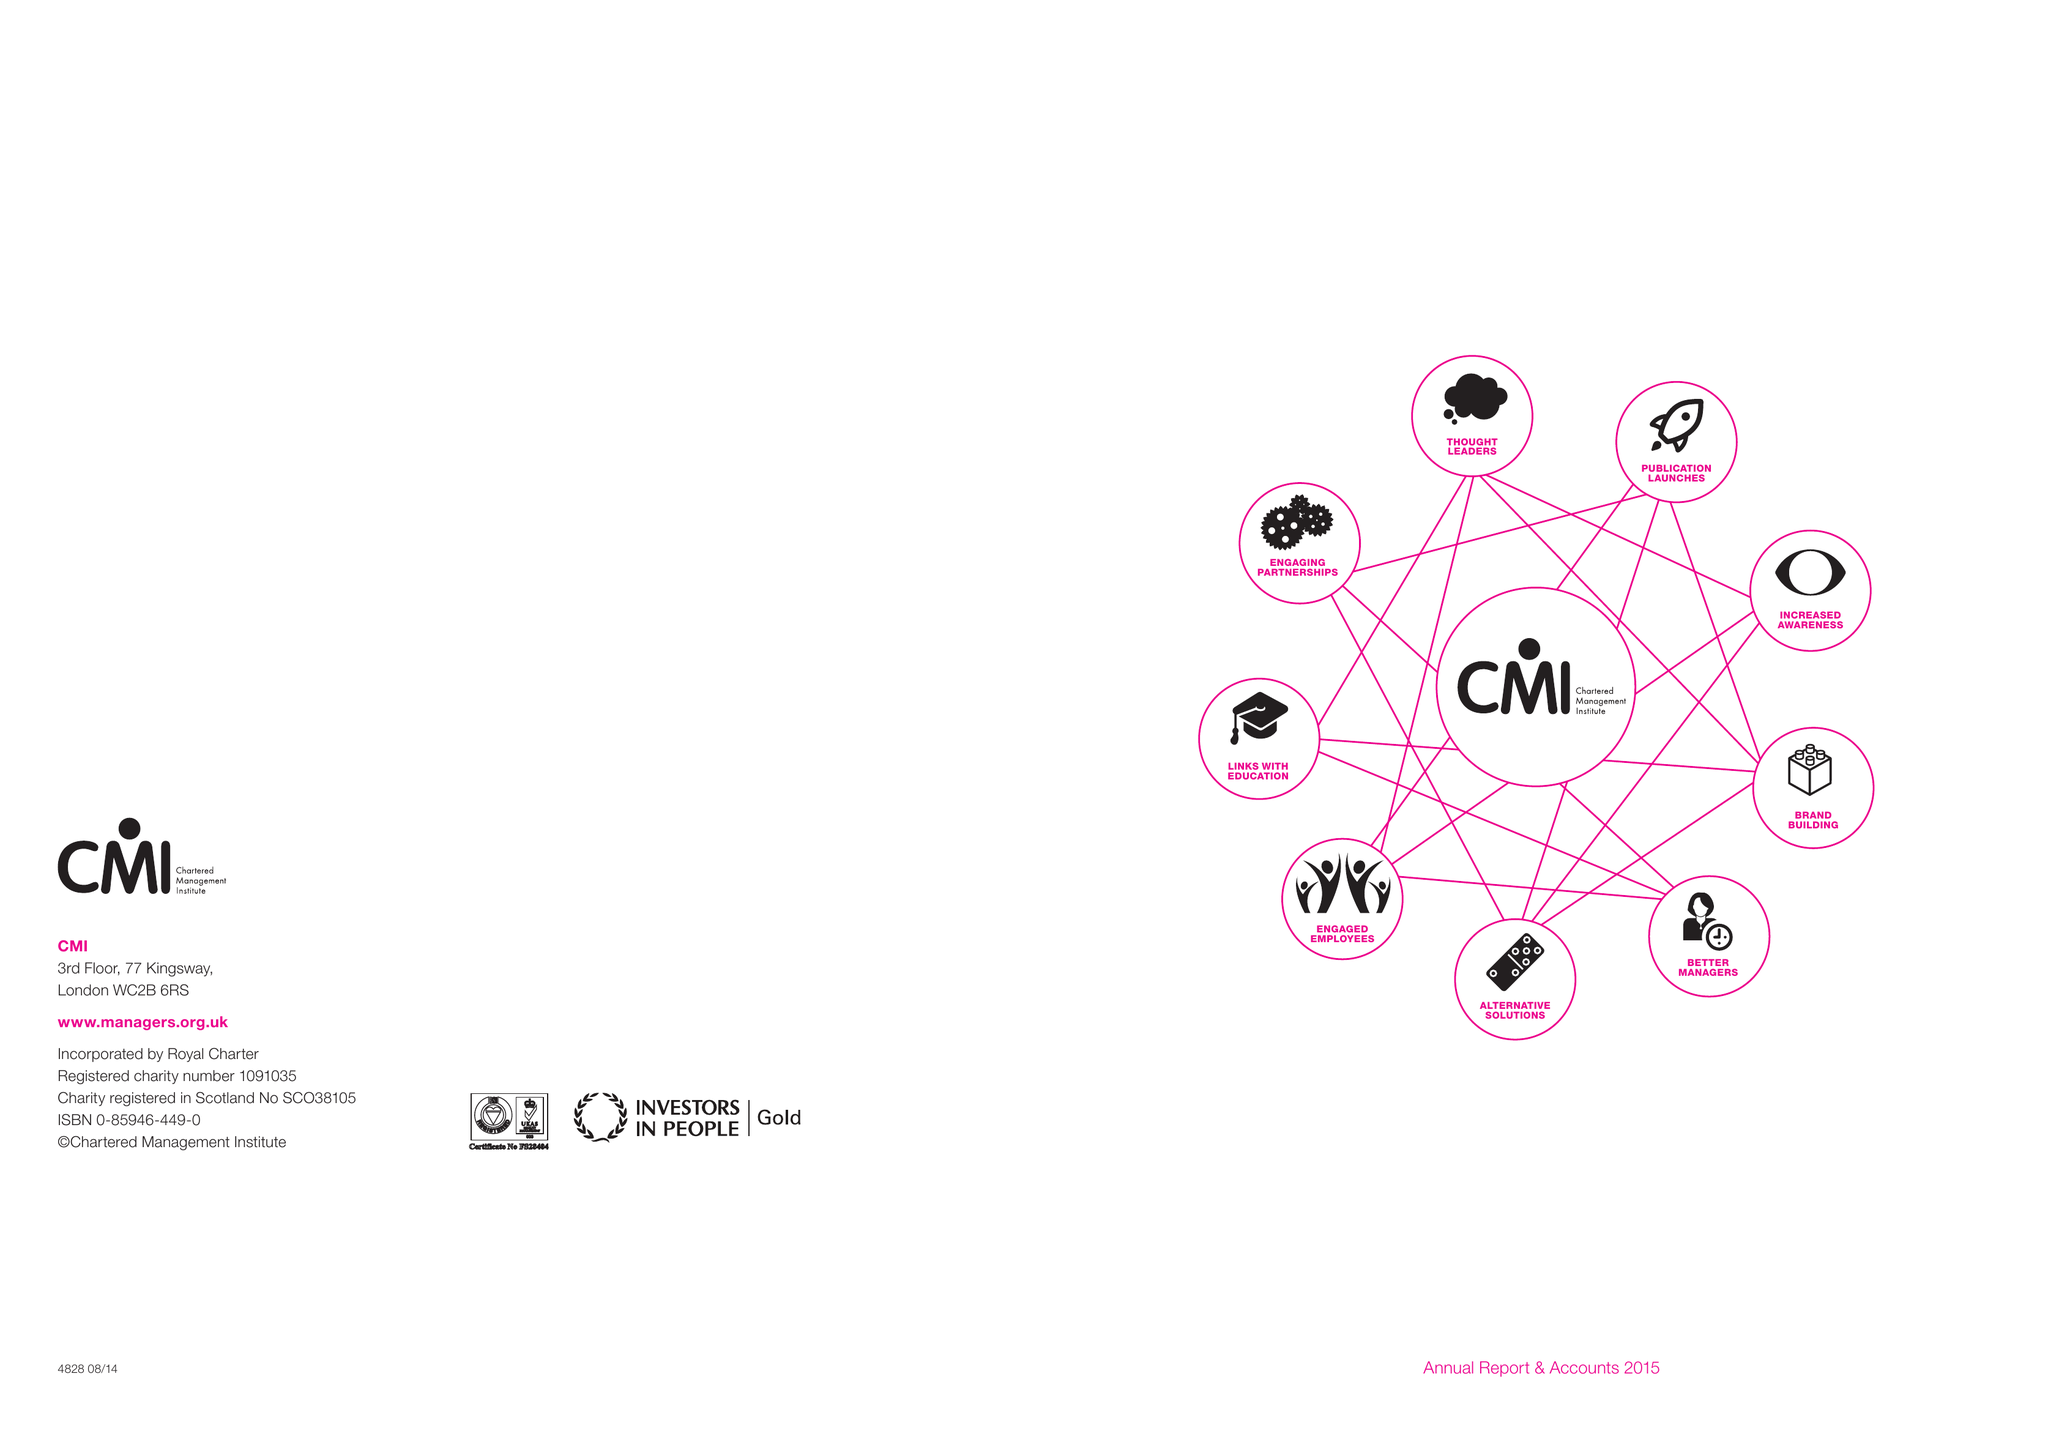What is the value for the address__postcode?
Answer the question using a single word or phrase. NN17 1TT 